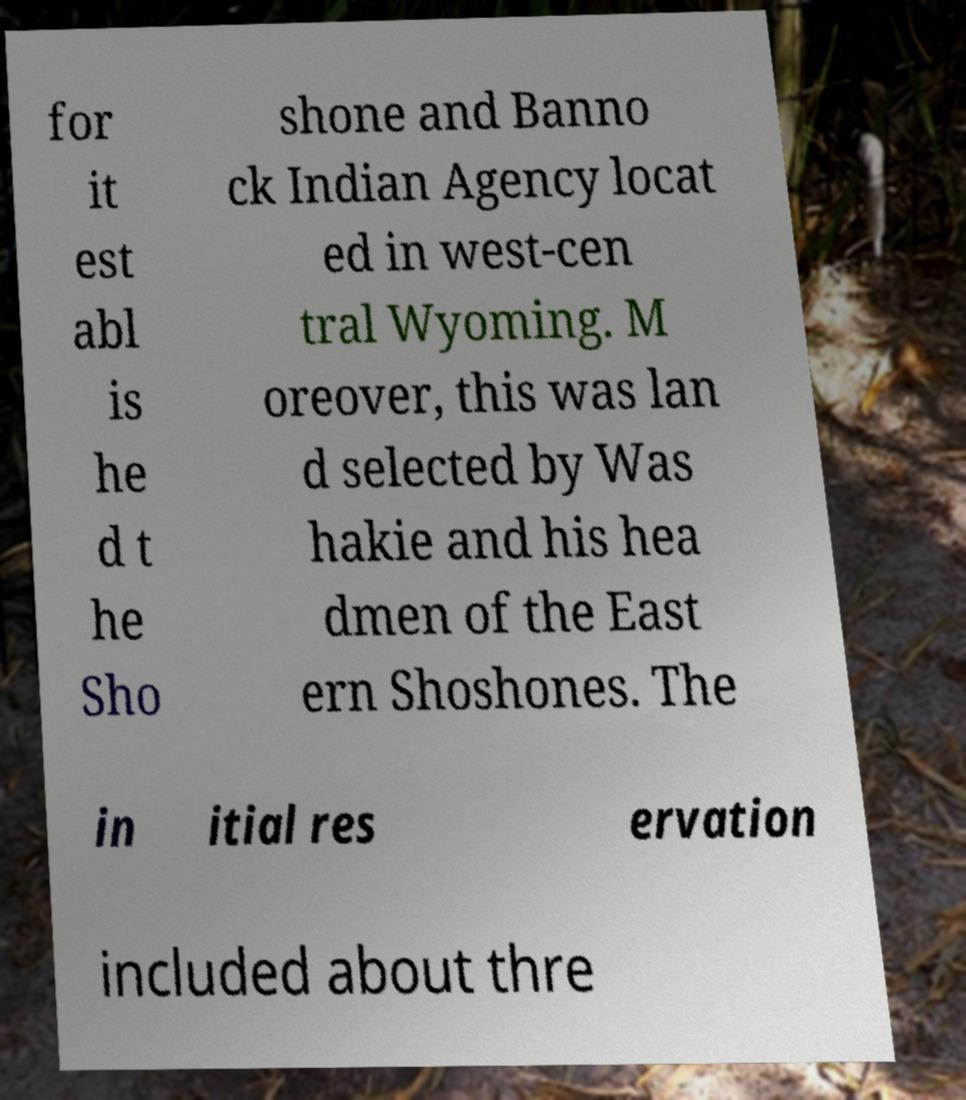What messages or text are displayed in this image? I need them in a readable, typed format. for it est abl is he d t he Sho shone and Banno ck Indian Agency locat ed in west-cen tral Wyoming. M oreover, this was lan d selected by Was hakie and his hea dmen of the East ern Shoshones. The in itial res ervation included about thre 